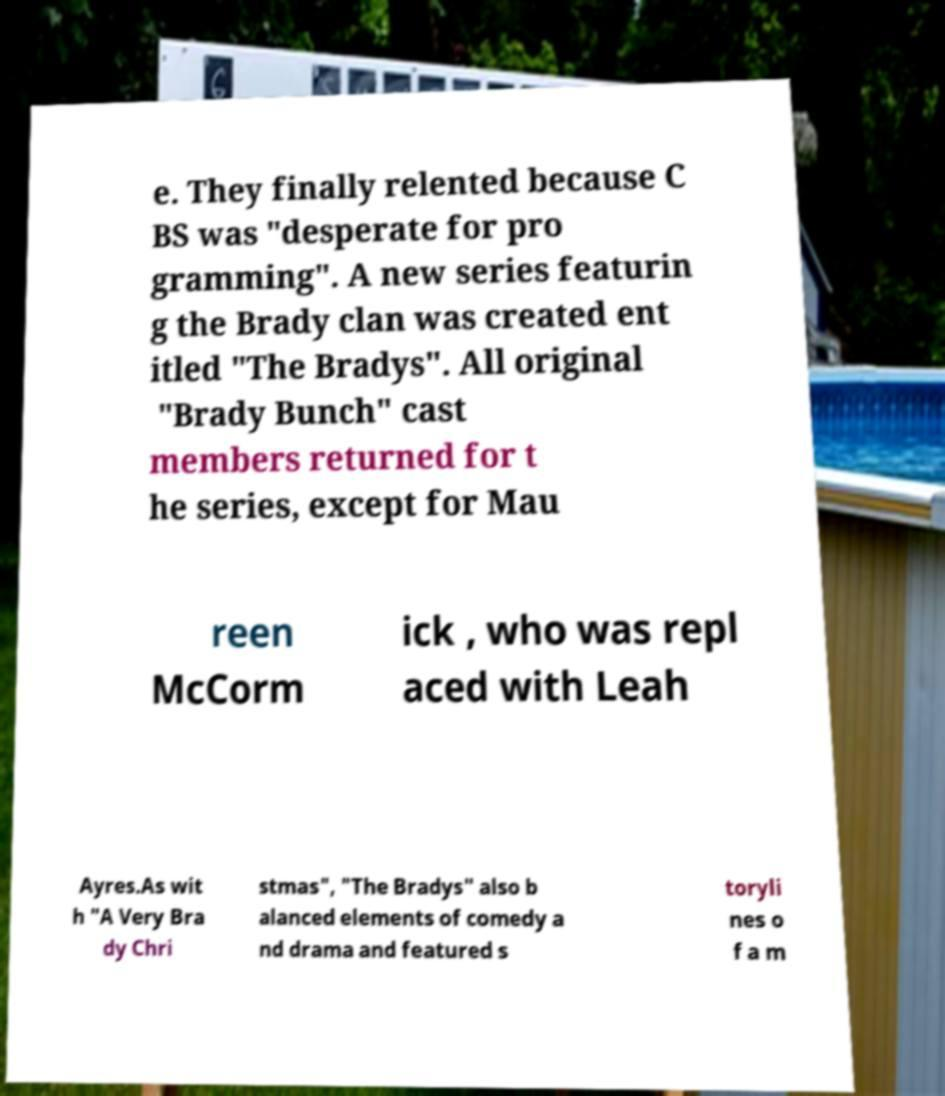Please identify and transcribe the text found in this image. e. They finally relented because C BS was "desperate for pro gramming". A new series featurin g the Brady clan was created ent itled "The Bradys". All original "Brady Bunch" cast members returned for t he series, except for Mau reen McCorm ick , who was repl aced with Leah Ayres.As wit h "A Very Bra dy Chri stmas", "The Bradys" also b alanced elements of comedy a nd drama and featured s toryli nes o f a m 